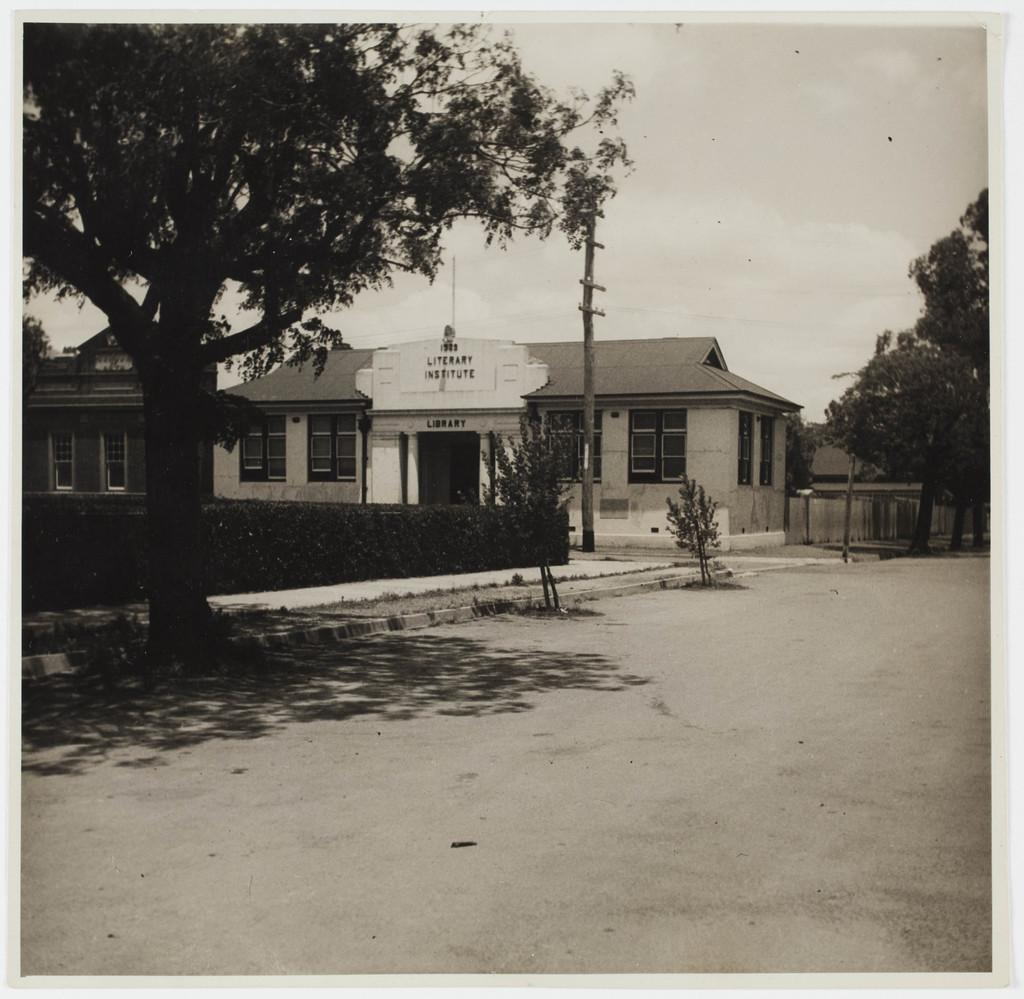What is the color scheme of the image? The image is black and white. What type of structure can be seen in the image? There is a house in the image. What other objects are present in the image? There is an electric pole, trees, a road, and plants in the image. What is visible at the top of the image? The sky is visible at the top of the image. How much money is being exchanged between the pets in the image? There are no pets present in the image, and therefore no money exchange can be observed. 